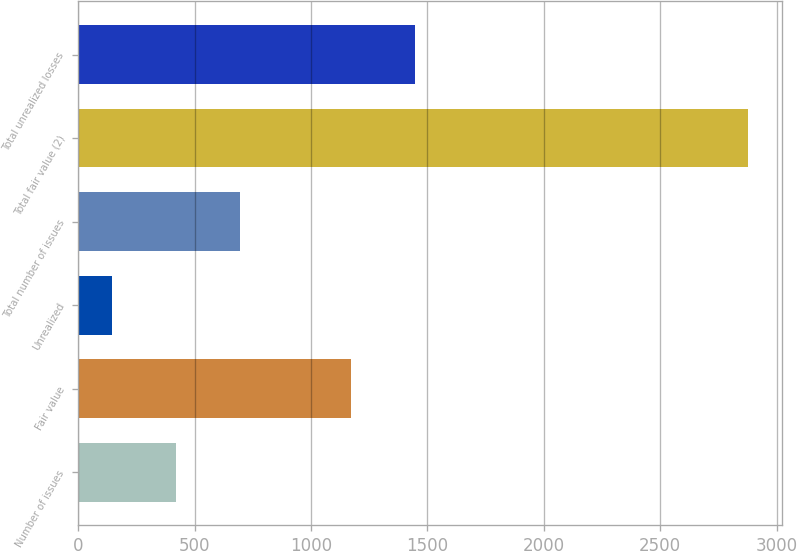Convert chart. <chart><loc_0><loc_0><loc_500><loc_500><bar_chart><fcel>Number of issues<fcel>Fair value<fcel>Unrealized<fcel>Total number of issues<fcel>Total fair value (2)<fcel>Total unrealized losses<nl><fcel>420.2<fcel>1172<fcel>147<fcel>693.4<fcel>2879<fcel>1445.2<nl></chart> 